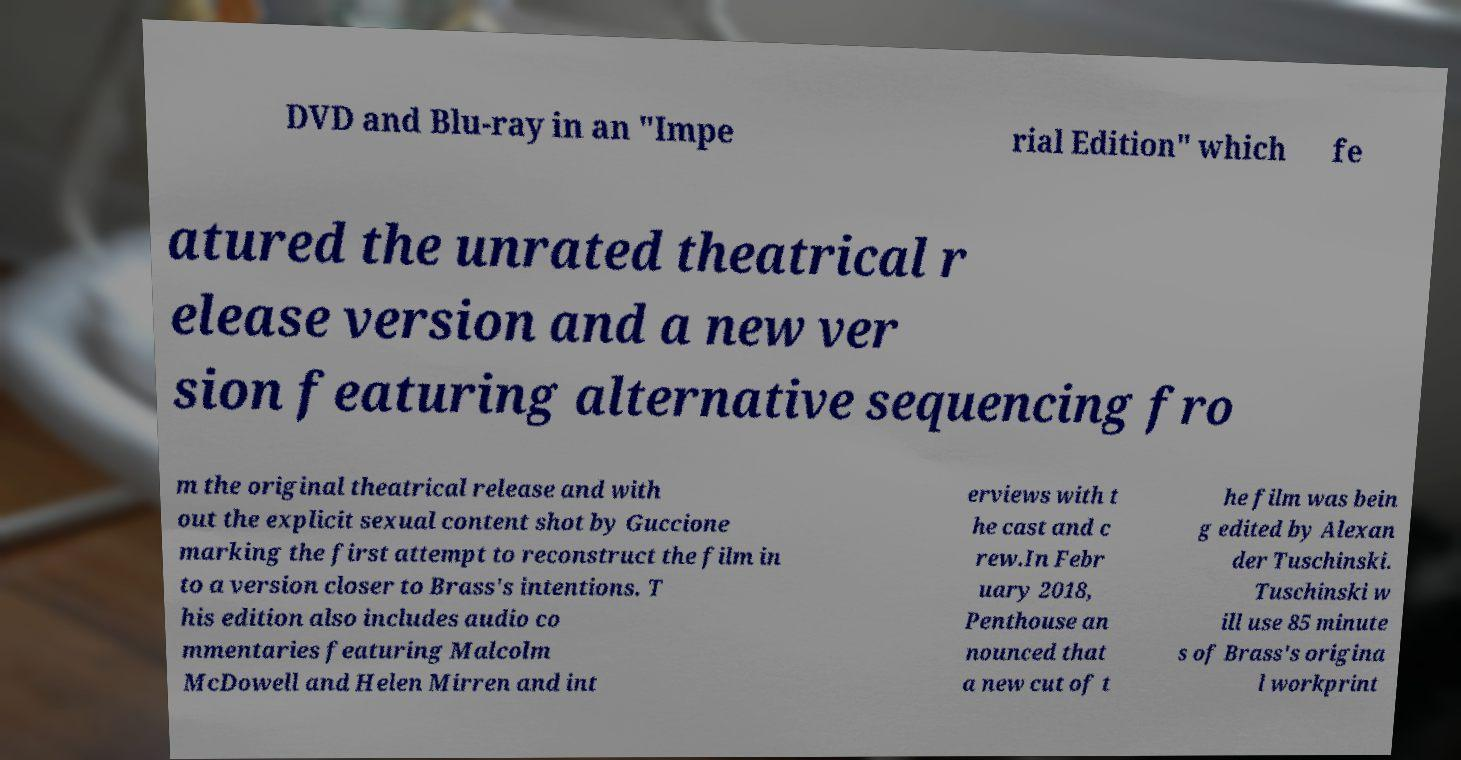Can you accurately transcribe the text from the provided image for me? DVD and Blu-ray in an "Impe rial Edition" which fe atured the unrated theatrical r elease version and a new ver sion featuring alternative sequencing fro m the original theatrical release and with out the explicit sexual content shot by Guccione marking the first attempt to reconstruct the film in to a version closer to Brass's intentions. T his edition also includes audio co mmentaries featuring Malcolm McDowell and Helen Mirren and int erviews with t he cast and c rew.In Febr uary 2018, Penthouse an nounced that a new cut of t he film was bein g edited by Alexan der Tuschinski. Tuschinski w ill use 85 minute s of Brass's origina l workprint 